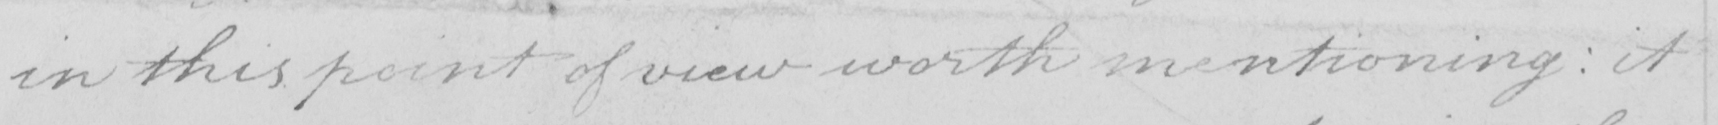Can you read and transcribe this handwriting? in this point of view worth mentioning  :  it 